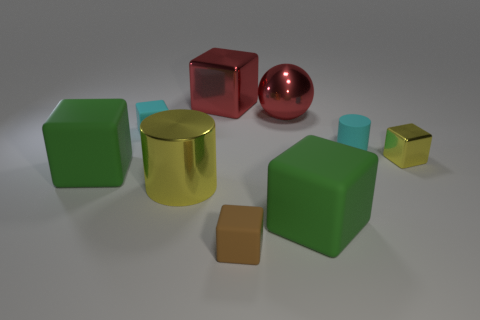What number of large green spheres are there?
Your response must be concise. 0. There is a brown object; is its size the same as the cylinder that is to the left of the tiny rubber cylinder?
Offer a very short reply. No. What material is the tiny cyan thing that is to the right of the tiny rubber object behind the small cyan cylinder?
Make the answer very short. Rubber. Is the number of big metal cubes the same as the number of tiny red cylinders?
Give a very brief answer. No. There is a green object on the right side of the large rubber thing on the left side of the green rubber object that is to the right of the cyan rubber block; what is its size?
Make the answer very short. Large. There is a tiny brown thing; is it the same shape as the yellow object on the left side of the tiny metallic object?
Give a very brief answer. No. What is the tiny cyan cylinder made of?
Give a very brief answer. Rubber. How many rubber objects are tiny brown things or red blocks?
Your answer should be compact. 1. Are there fewer large shiny things in front of the large red shiny cube than objects that are in front of the red sphere?
Your answer should be compact. Yes. Is there a cyan block that is on the right side of the cyan rubber object left of the cyan thing in front of the tiny cyan matte block?
Your answer should be very brief. No. 